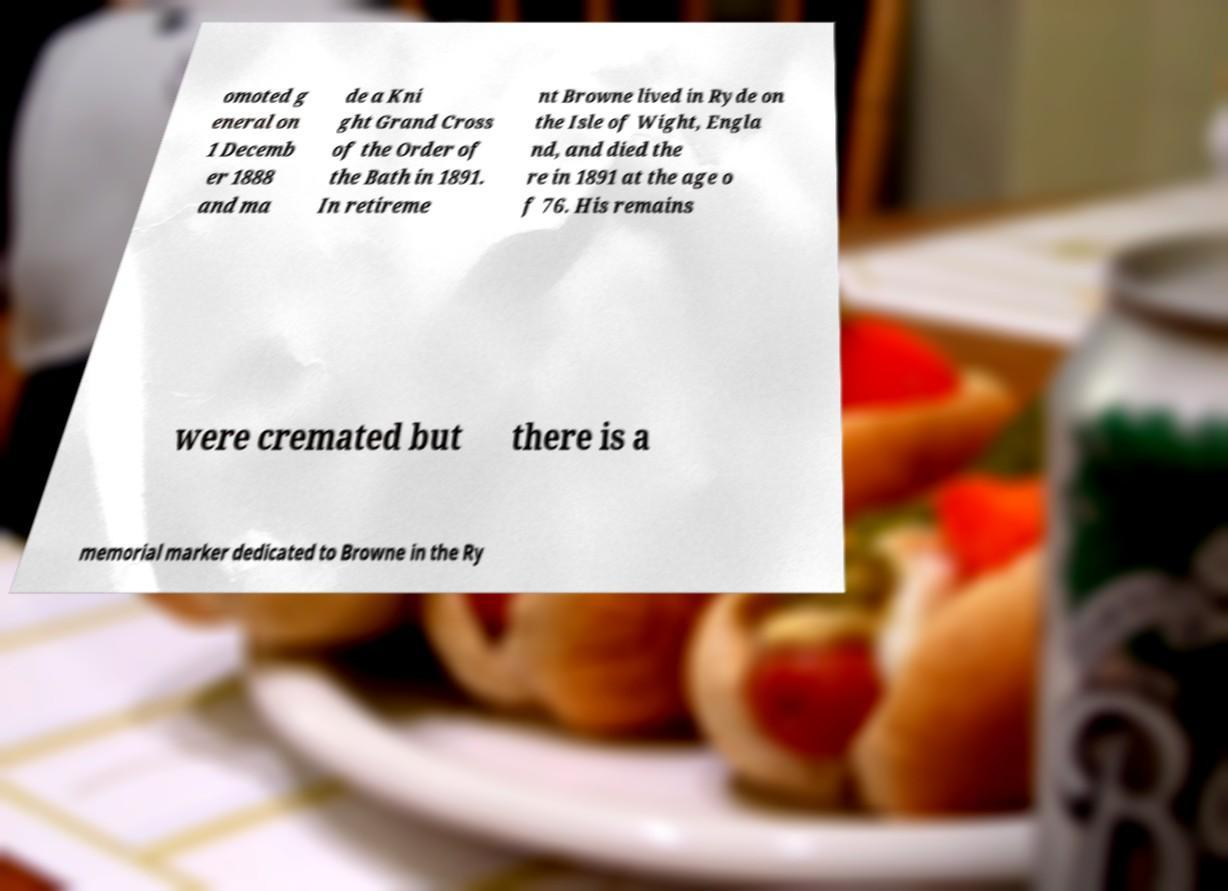Can you accurately transcribe the text from the provided image for me? omoted g eneral on 1 Decemb er 1888 and ma de a Kni ght Grand Cross of the Order of the Bath in 1891. In retireme nt Browne lived in Ryde on the Isle of Wight, Engla nd, and died the re in 1891 at the age o f 76. His remains were cremated but there is a memorial marker dedicated to Browne in the Ry 